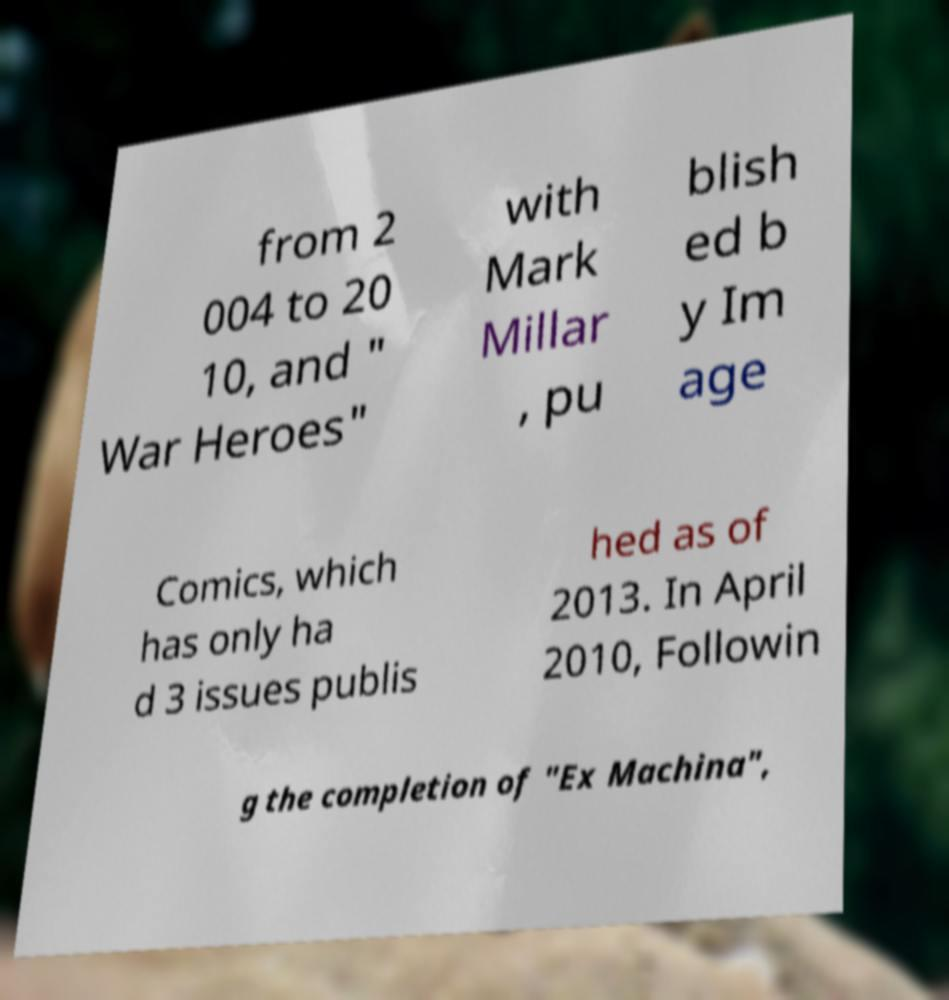What messages or text are displayed in this image? I need them in a readable, typed format. from 2 004 to 20 10, and " War Heroes" with Mark Millar , pu blish ed b y Im age Comics, which has only ha d 3 issues publis hed as of 2013. In April 2010, Followin g the completion of "Ex Machina", 